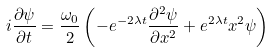<formula> <loc_0><loc_0><loc_500><loc_500>i \frac { \partial \psi } { \partial t } = \frac { \omega _ { 0 } } { 2 } \left ( - e ^ { - 2 \lambda t } \frac { \partial ^ { 2 } \psi } { \partial x ^ { 2 } } + e ^ { 2 \lambda t } x ^ { 2 } \psi \right )</formula> 